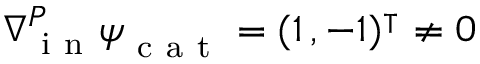<formula> <loc_0><loc_0><loc_500><loc_500>_ { i n } ^ { P } \boldsymbol \psi _ { c a t } = ( 1 \, , - 1 ) ^ { \intercal } \neq 0</formula> 